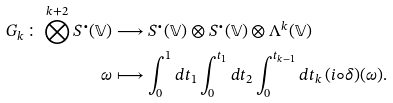Convert formula to latex. <formula><loc_0><loc_0><loc_500><loc_500>G _ { k } \colon \bigotimes ^ { k + 2 } S ^ { \bullet } ( \mathbb { V } ) & \longrightarrow S ^ { \bullet } ( \mathbb { V } ) \otimes S ^ { \bullet } ( \mathbb { V } ) \otimes \Lambda ^ { k } ( \mathbb { V } ) \\ \omega & \longmapsto \int _ { 0 } ^ { 1 } d t _ { 1 } \int _ { 0 } ^ { t _ { 1 } } d t _ { 2 } \int _ { 0 } ^ { t _ { k - 1 } } d t _ { k } \, ( i \circ \delta ) ( \omega ) .</formula> 